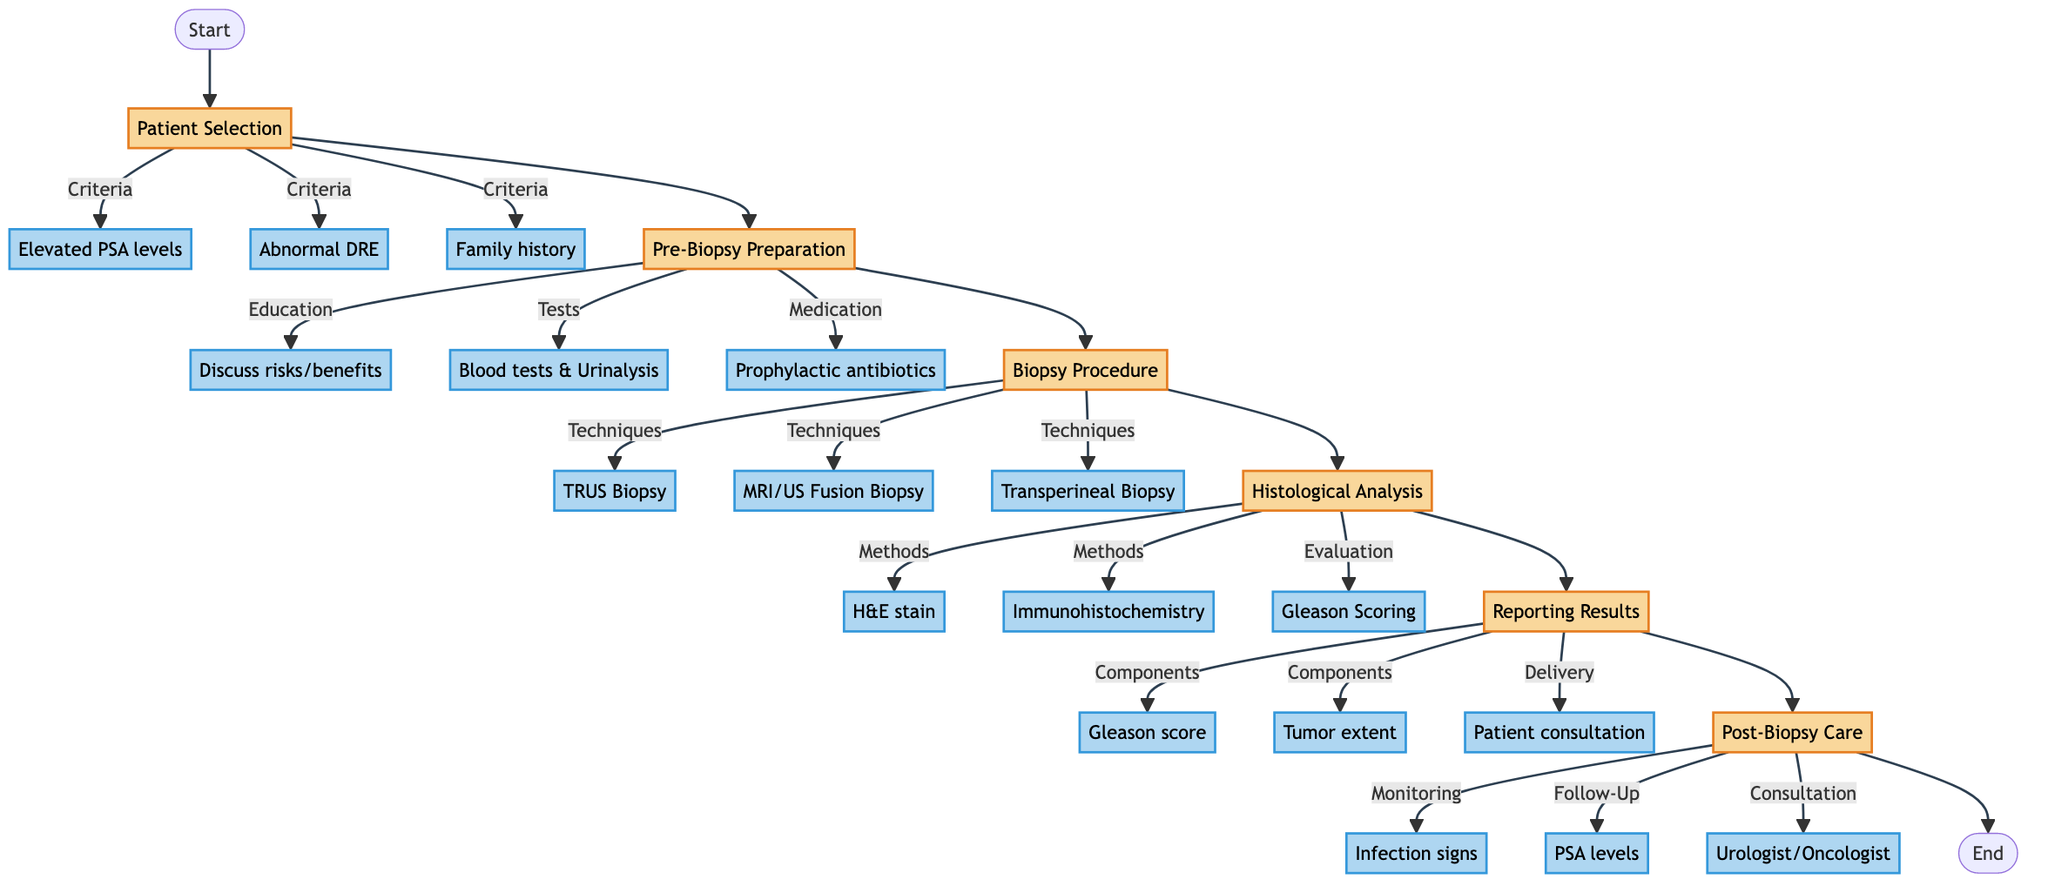What is the first step in the workflow? The first step in the workflow is labeled "Patient Selection," indicating it is the starting point for evaluating histological outcomes of prostate biopsies.
Answer: Patient Selection How many biopsy techniques are mentioned? By checking the "Biopsy Procedure" section, we see there are three techniques listed: Transrectal Ultrasound-Guided Biopsy, MRI/Ultrasound Fusion Biopsy, and Transperineal Biopsy.
Answer: 3 Which component is included in the pathology report? The "Reporting Results" step lists several components, including the Gleason score, tumor extent, and perineural invasion status. One option is the Gleason score, which is clearly mentioned.
Answer: Gleason score What is the purpose of patient education in the pre-biopsy preparation? Patient education aims to inform the patient about potential risks and benefits, explain the procedure, and obtain informed consent, making it crucial for informed decision-making before the biopsy.
Answer: Informed consent Which tests are included in the pre-biopsy preparation? The "Pre-Biopsy Tests" section specifically indicates "Blood tests" and "Urinalysis" as part of the preparation prior to performing the biopsy.
Answer: Blood tests, Urinalysis What is the typical number of cores sampled during the biopsy procedure? The "Biopsy Procedure" step specifies that typically 10-12 cores are sampled during the biopsy. By looking directly at this information, we can determine the typical number.
Answer: 10-12 cores What are the two staining methods used in histological analysis? In the "Histological Analysis" step, it specifically mentions two methods: Hematoxylin and Eosin stain and Immunohistochemistry. Therefore, these two methods are used for analyzing histological outcomes.
Answer: H&E stain, Immunohistochemistry What is the final step in the workflow? The last step indicated in the workflow is "Post-Biopsy Care," which follows all previous steps and encompasses the care needed after the biopsy procedure.
Answer: Post-Biopsy Care 